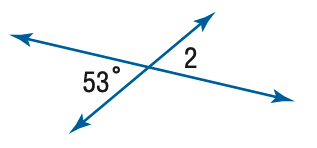Answer the mathemtical geometry problem and directly provide the correct option letter.
Question: Find the measure of \angle 2.
Choices: A: 53 B: 63 C: 73 D: 83 A 